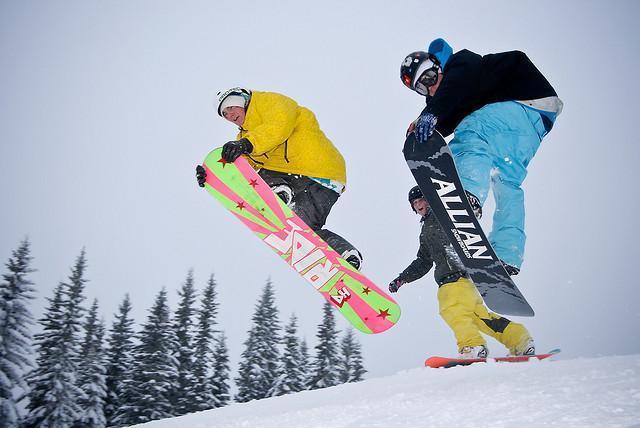How many snowboarders are there?
Give a very brief answer. 3. How many ski poles is the person holding?
Give a very brief answer. 0. How many snowboards are visible?
Give a very brief answer. 2. How many people are in the picture?
Give a very brief answer. 3. 